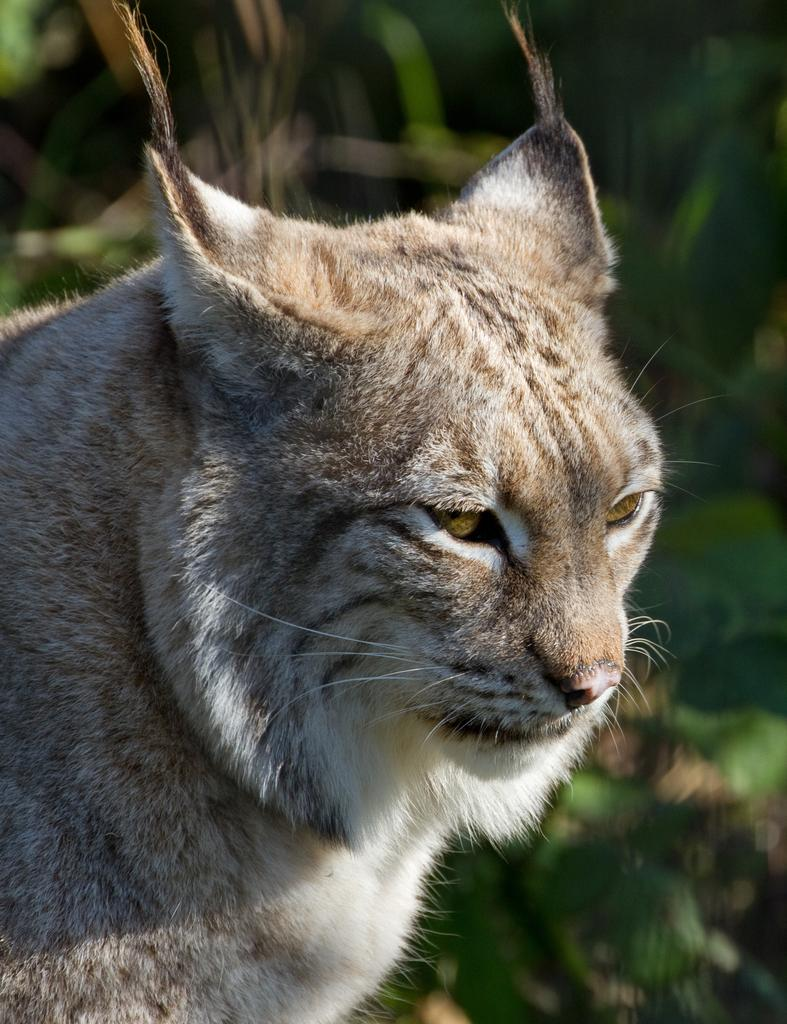What type of animal is in the picture? There is a bobcat in the picture. What can be seen in the background of the picture? There appear to be trees in the background of the picture. What type of food is the bobcat offering to the trees in the picture? There is no food or offering present in the image; it simply shows a bobcat and trees in the background. 